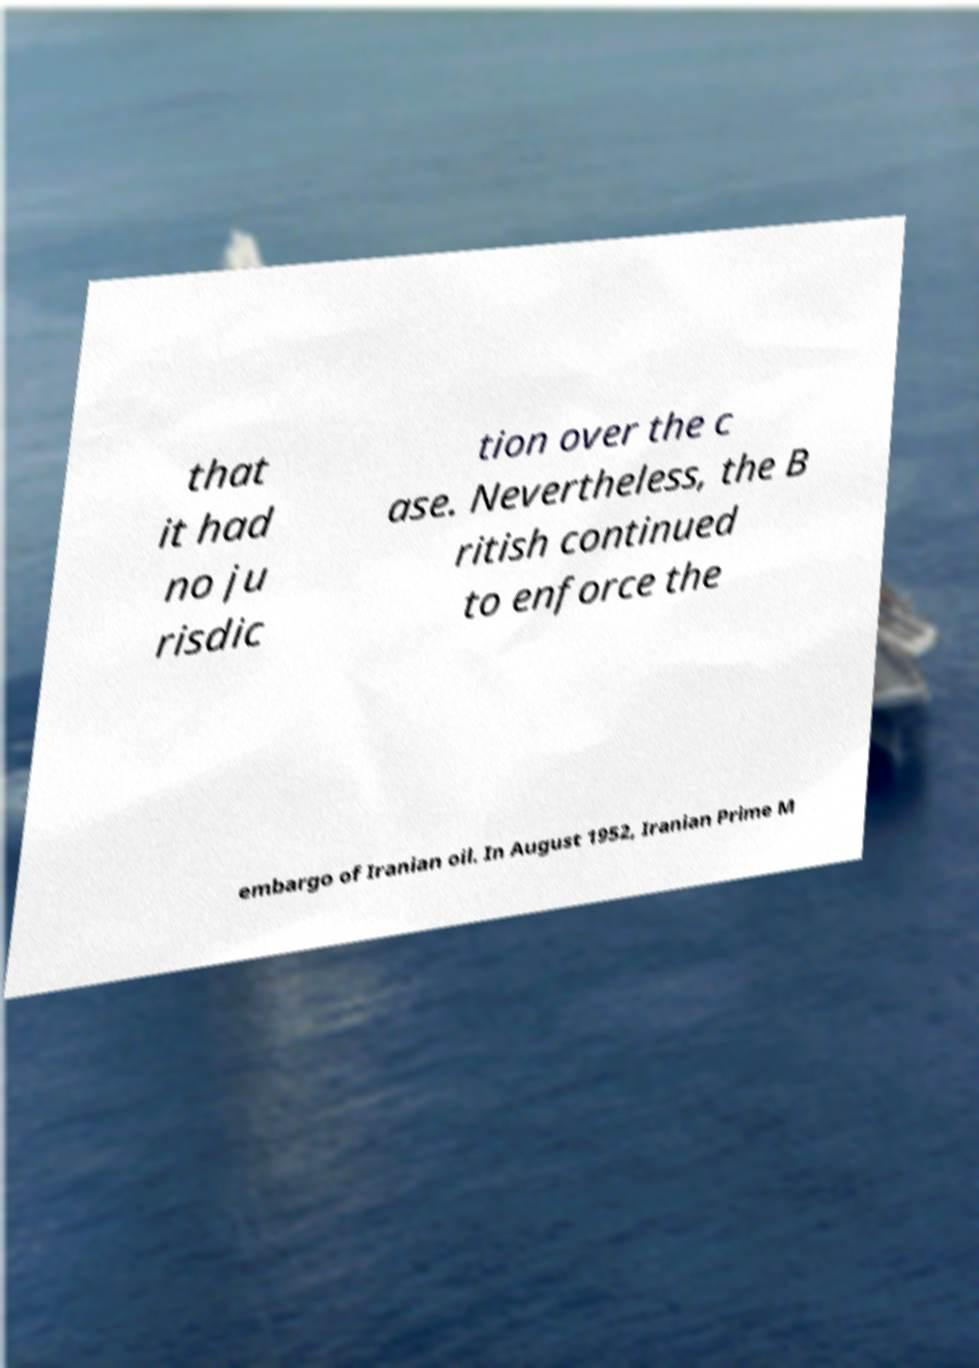Can you read and provide the text displayed in the image?This photo seems to have some interesting text. Can you extract and type it out for me? that it had no ju risdic tion over the c ase. Nevertheless, the B ritish continued to enforce the embargo of Iranian oil. In August 1952, Iranian Prime M 